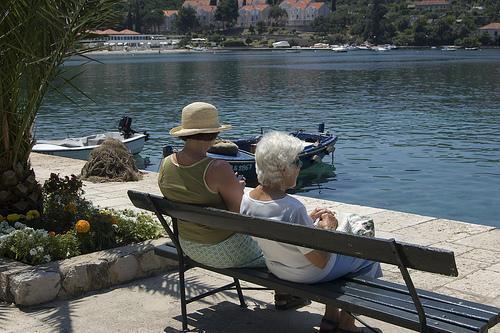How many people are in the photo?
Give a very brief answer. 2. How many people are wearing hat?
Give a very brief answer. 1. 